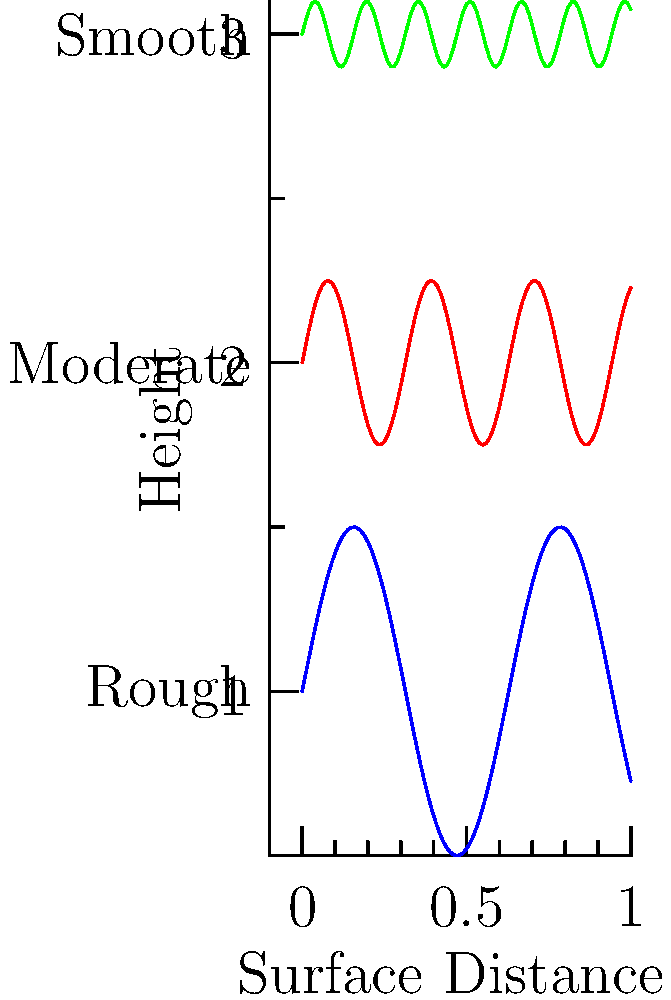Which dental implant surface texture, as shown in the graph, is most likely to promote rapid osseointegration and why? To answer this question, we need to consider the relationship between surface texture and osseointegration:

1. The graph shows three different surface textures: rough (blue), moderate (red), and smooth (green).

2. Osseointegration is the process by which bone tissue integrates with the implant surface.

3. Surface roughness affects the implant's surface area:
   - Rough surfaces have more peaks and valleys, increasing the total surface area.
   - Smooth surfaces have fewer irregularities and thus less surface area.

4. A larger surface area provides:
   - More attachment points for osteoblasts (bone-forming cells).
   - Increased mechanical interlocking between the implant and bone.

5. Rough surfaces also create micro-environments that can:
   - Trap proteins and growth factors.
   - Enhance cell adhesion and proliferation.

6. Studies have shown that moderately rough surfaces (Sa values between 1-2 μm) tend to have the best balance for osseointegration.

7. The blue line in the graph represents the roughest surface, which is most likely to promote rapid osseointegration due to its increased surface area and ability to create beneficial micro-environments.
Answer: Rough surface (blue line) 